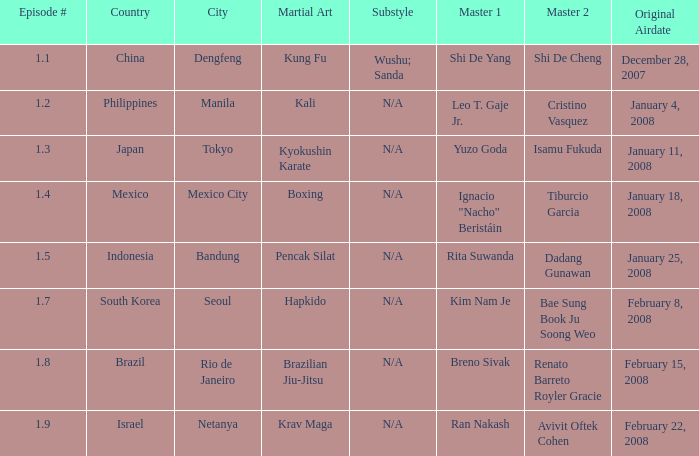When did the episode featuring a master using Brazilian jiu-jitsu air? February 15, 2008. 